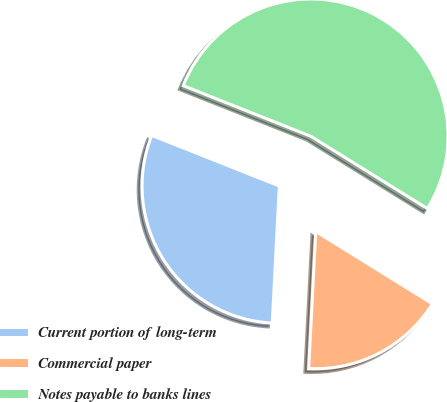<chart> <loc_0><loc_0><loc_500><loc_500><pie_chart><fcel>Current portion of long-term<fcel>Commercial paper<fcel>Notes payable to banks lines<nl><fcel>30.19%<fcel>16.98%<fcel>52.83%<nl></chart> 